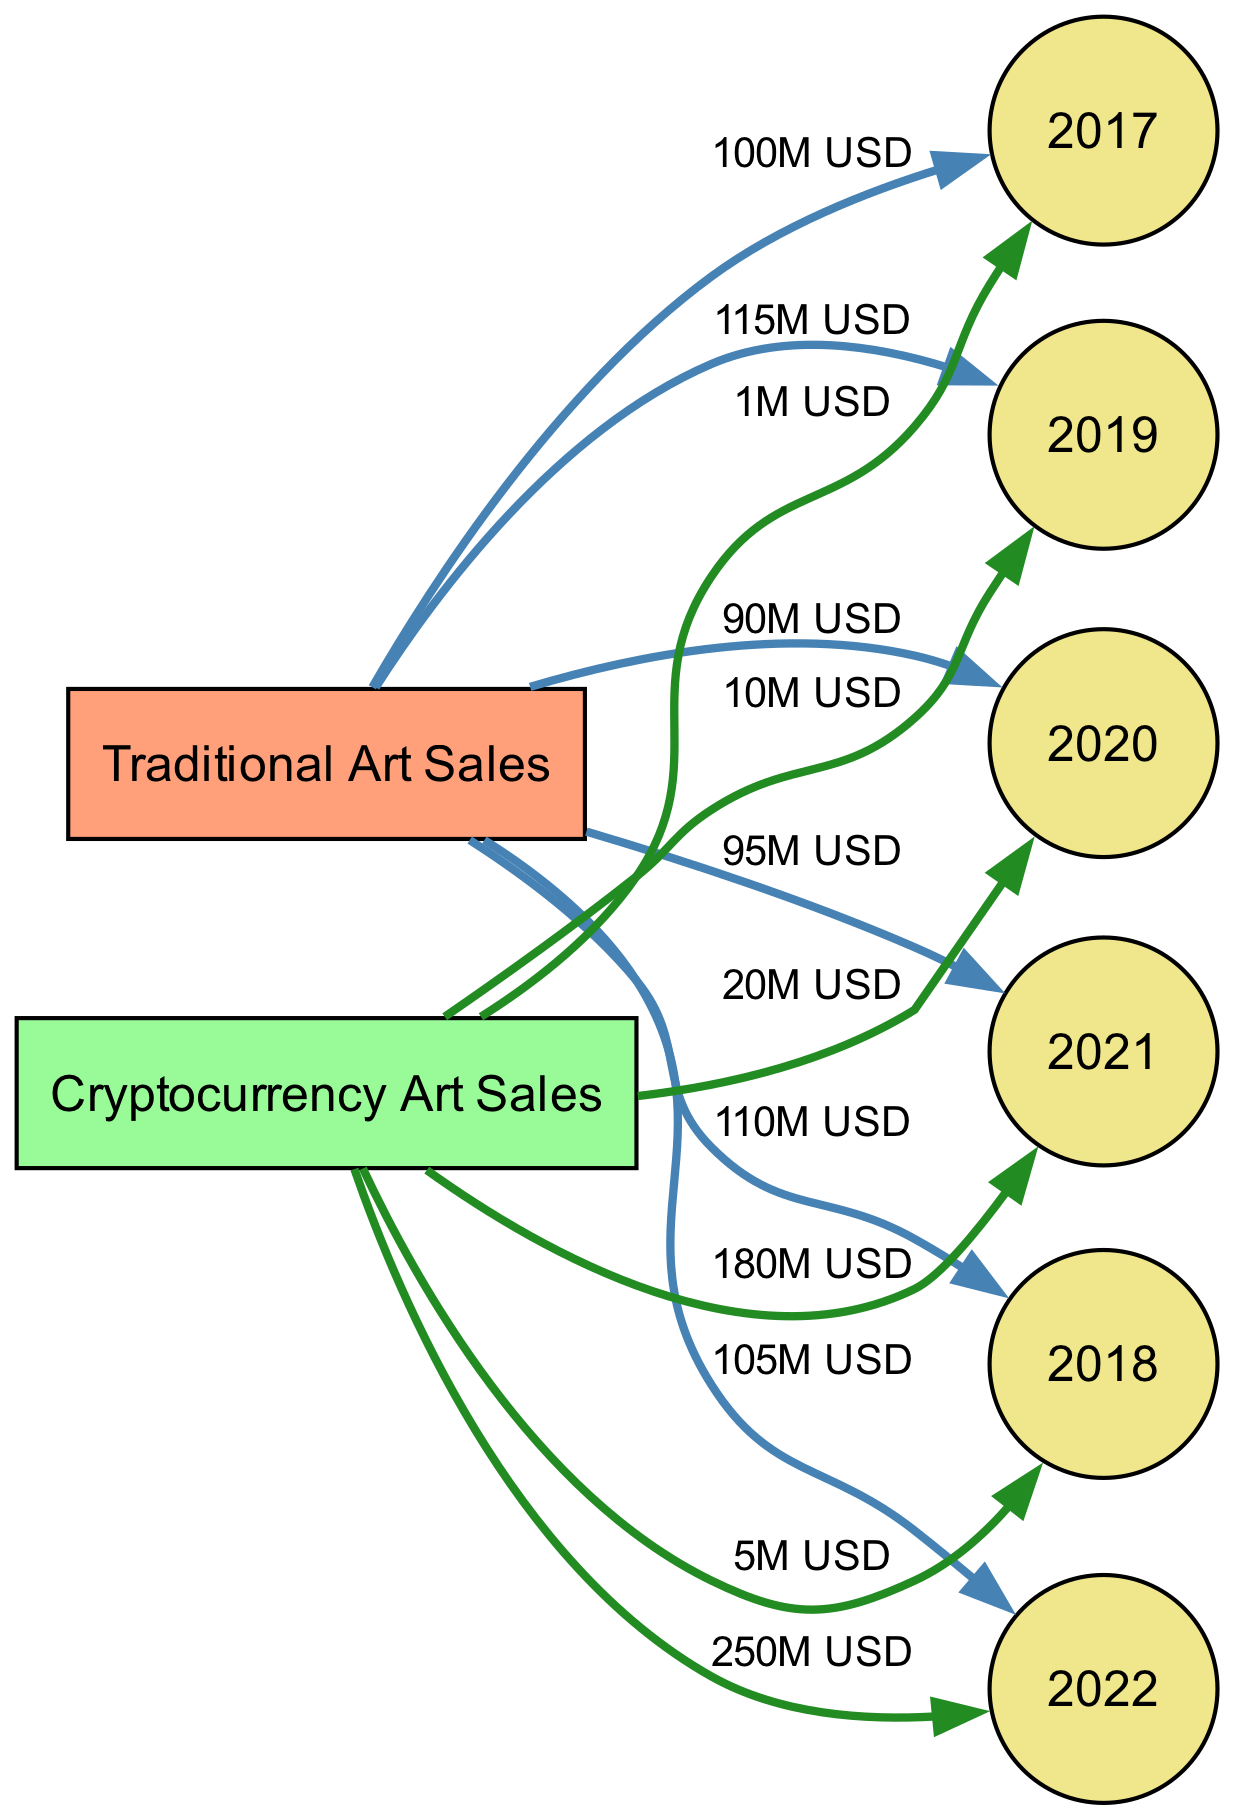What were the total sales for Traditional Art in 2020? By examining the edge labeled between the "Traditional Art Sales" node and the "2020 Sales" node, we find the label indicates "90M USD". This is the total sales for that year.
Answer: 90M USD What were the Cryptocurrency Art Sales in 2021? Looking at the edge connecting "Cryptocurrency Art Sales" to "2021 Sales", the label reads "180M USD". Thus, this is the sales total for Cryptocurrency Art in 2021.
Answer: 180M USD How many nodes are present in the diagram? Counting each unique node listed, there are eight nodes representing the categories of art sales and the specific years for sales data, with six distinct years plus two main categories.
Answer: 8 What was the sales trend for Traditional Art from 2017 to 2022? By observing the sales values over the years from the "Traditional Art Sales" node, we can see: 100M, 110M, 115M, 90M, 95M, and 105M. This indicates fluctuations, with a peak in 2019 followed by a drop in 2020.
Answer: Fluctuating Which year had the highest Cryptocurrency sales? Analyzing the edges, the highest sales figure is found at the "2022 Sales" node, which is labeled "250M USD". Thus, this year had the highest sales for Cryptocurrency art.
Answer: 2022 What was the percentage increase of Cryptocurrency sales from 2019 to 2022? First, we find the sales values for 2019 and 2022: "10M USD" for 2019 and "250M USD" for 2022. The formula for percentage increase is ((new value - old value) / old value) * 100. Therefore, ((250M - 10M) / 10M) * 100 = 2400%.
Answer: 2400% What is the total sales for all years in Cryptocurrency? Adding the sales from the "Cryptocurrency Art Sales" edges: 1M + 5M + 10M + 20M + 180M + 250M = 466M USD. This gives the total sales for Cryptocurrency over these years.
Answer: 466M USD How did Traditional Art sales in 2019 compare to 2022? Comparing the edges for Traditional Art, 2019 had sales of "115M USD", while 2022 sales were "105M USD". This indicates a decrease in sales from 2019 to 2022.
Answer: Decrease What label represents the relationship between Traditional Art Sales and 2018 Sales? The edge connecting these two nodes has the label "110M USD". This indicates the sales figure for Traditional Art in the year 2018.
Answer: 110M USD 